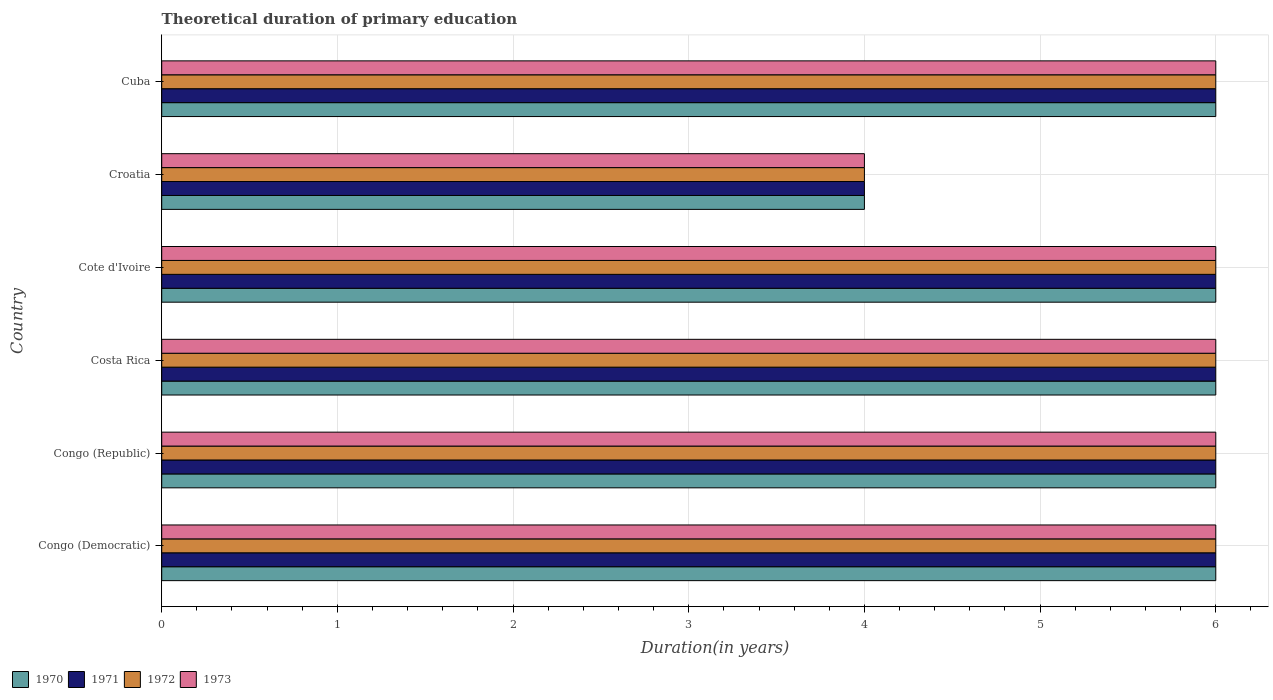How many different coloured bars are there?
Give a very brief answer. 4. What is the label of the 3rd group of bars from the top?
Your answer should be compact. Cote d'Ivoire. What is the total theoretical duration of primary education in 1973 in Croatia?
Give a very brief answer. 4. Across all countries, what is the maximum total theoretical duration of primary education in 1970?
Offer a very short reply. 6. Across all countries, what is the minimum total theoretical duration of primary education in 1972?
Provide a short and direct response. 4. In which country was the total theoretical duration of primary education in 1971 maximum?
Your response must be concise. Congo (Democratic). In which country was the total theoretical duration of primary education in 1970 minimum?
Offer a terse response. Croatia. What is the total total theoretical duration of primary education in 1972 in the graph?
Offer a very short reply. 34. What is the difference between the total theoretical duration of primary education in 1972 in Congo (Democratic) and the total theoretical duration of primary education in 1973 in Cote d'Ivoire?
Offer a terse response. 0. What is the average total theoretical duration of primary education in 1972 per country?
Your answer should be compact. 5.67. What is the difference between the total theoretical duration of primary education in 1971 and total theoretical duration of primary education in 1973 in Croatia?
Offer a terse response. 0. Is the total theoretical duration of primary education in 1973 in Cote d'Ivoire less than that in Croatia?
Offer a terse response. No. Is the difference between the total theoretical duration of primary education in 1971 in Cote d'Ivoire and Croatia greater than the difference between the total theoretical duration of primary education in 1973 in Cote d'Ivoire and Croatia?
Your response must be concise. No. What is the difference between the highest and the second highest total theoretical duration of primary education in 1972?
Ensure brevity in your answer.  0. What does the 1st bar from the top in Costa Rica represents?
Ensure brevity in your answer.  1973. How many bars are there?
Your response must be concise. 24. Are the values on the major ticks of X-axis written in scientific E-notation?
Provide a succinct answer. No. Where does the legend appear in the graph?
Keep it short and to the point. Bottom left. How many legend labels are there?
Your response must be concise. 4. How are the legend labels stacked?
Your answer should be compact. Horizontal. What is the title of the graph?
Your answer should be compact. Theoretical duration of primary education. What is the label or title of the X-axis?
Give a very brief answer. Duration(in years). What is the label or title of the Y-axis?
Give a very brief answer. Country. What is the Duration(in years) of 1970 in Congo (Democratic)?
Provide a succinct answer. 6. What is the Duration(in years) in 1972 in Congo (Democratic)?
Keep it short and to the point. 6. What is the Duration(in years) of 1973 in Congo (Democratic)?
Your response must be concise. 6. What is the Duration(in years) in 1971 in Congo (Republic)?
Offer a very short reply. 6. What is the Duration(in years) of 1972 in Congo (Republic)?
Keep it short and to the point. 6. What is the Duration(in years) in 1973 in Congo (Republic)?
Keep it short and to the point. 6. What is the Duration(in years) of 1970 in Costa Rica?
Give a very brief answer. 6. What is the Duration(in years) in 1971 in Costa Rica?
Your answer should be compact. 6. What is the Duration(in years) in 1973 in Costa Rica?
Your answer should be very brief. 6. What is the Duration(in years) of 1970 in Cote d'Ivoire?
Provide a succinct answer. 6. What is the Duration(in years) of 1972 in Cote d'Ivoire?
Ensure brevity in your answer.  6. What is the Duration(in years) in 1973 in Cote d'Ivoire?
Ensure brevity in your answer.  6. What is the Duration(in years) of 1970 in Croatia?
Give a very brief answer. 4. What is the Duration(in years) in 1972 in Cuba?
Make the answer very short. 6. What is the Duration(in years) of 1973 in Cuba?
Provide a succinct answer. 6. Across all countries, what is the maximum Duration(in years) in 1970?
Offer a terse response. 6. Across all countries, what is the maximum Duration(in years) of 1973?
Keep it short and to the point. 6. Across all countries, what is the minimum Duration(in years) in 1973?
Provide a succinct answer. 4. What is the total Duration(in years) of 1970 in the graph?
Your answer should be compact. 34. What is the difference between the Duration(in years) of 1971 in Congo (Democratic) and that in Congo (Republic)?
Provide a succinct answer. 0. What is the difference between the Duration(in years) in 1973 in Congo (Democratic) and that in Congo (Republic)?
Make the answer very short. 0. What is the difference between the Duration(in years) in 1970 in Congo (Democratic) and that in Cote d'Ivoire?
Your answer should be compact. 0. What is the difference between the Duration(in years) in 1972 in Congo (Democratic) and that in Cote d'Ivoire?
Your answer should be very brief. 0. What is the difference between the Duration(in years) of 1970 in Congo (Democratic) and that in Croatia?
Provide a short and direct response. 2. What is the difference between the Duration(in years) in 1973 in Congo (Democratic) and that in Croatia?
Offer a very short reply. 2. What is the difference between the Duration(in years) in 1970 in Congo (Democratic) and that in Cuba?
Offer a terse response. 0. What is the difference between the Duration(in years) in 1971 in Congo (Democratic) and that in Cuba?
Offer a very short reply. 0. What is the difference between the Duration(in years) in 1973 in Congo (Democratic) and that in Cuba?
Provide a succinct answer. 0. What is the difference between the Duration(in years) in 1971 in Congo (Republic) and that in Costa Rica?
Ensure brevity in your answer.  0. What is the difference between the Duration(in years) in 1971 in Congo (Republic) and that in Cote d'Ivoire?
Give a very brief answer. 0. What is the difference between the Duration(in years) of 1973 in Congo (Republic) and that in Cote d'Ivoire?
Make the answer very short. 0. What is the difference between the Duration(in years) of 1971 in Congo (Republic) and that in Croatia?
Offer a very short reply. 2. What is the difference between the Duration(in years) of 1972 in Congo (Republic) and that in Croatia?
Provide a short and direct response. 2. What is the difference between the Duration(in years) in 1971 in Congo (Republic) and that in Cuba?
Offer a terse response. 0. What is the difference between the Duration(in years) in 1971 in Costa Rica and that in Cote d'Ivoire?
Give a very brief answer. 0. What is the difference between the Duration(in years) in 1970 in Costa Rica and that in Croatia?
Provide a succinct answer. 2. What is the difference between the Duration(in years) in 1971 in Costa Rica and that in Croatia?
Provide a short and direct response. 2. What is the difference between the Duration(in years) in 1972 in Costa Rica and that in Croatia?
Your answer should be very brief. 2. What is the difference between the Duration(in years) of 1970 in Costa Rica and that in Cuba?
Offer a very short reply. 0. What is the difference between the Duration(in years) in 1972 in Costa Rica and that in Cuba?
Your answer should be very brief. 0. What is the difference between the Duration(in years) in 1973 in Costa Rica and that in Cuba?
Provide a short and direct response. 0. What is the difference between the Duration(in years) in 1972 in Cote d'Ivoire and that in Croatia?
Provide a short and direct response. 2. What is the difference between the Duration(in years) of 1973 in Cote d'Ivoire and that in Croatia?
Offer a terse response. 2. What is the difference between the Duration(in years) of 1970 in Cote d'Ivoire and that in Cuba?
Your answer should be compact. 0. What is the difference between the Duration(in years) in 1972 in Cote d'Ivoire and that in Cuba?
Your answer should be compact. 0. What is the difference between the Duration(in years) of 1971 in Croatia and that in Cuba?
Ensure brevity in your answer.  -2. What is the difference between the Duration(in years) of 1972 in Croatia and that in Cuba?
Provide a succinct answer. -2. What is the difference between the Duration(in years) of 1973 in Croatia and that in Cuba?
Offer a very short reply. -2. What is the difference between the Duration(in years) in 1970 in Congo (Democratic) and the Duration(in years) in 1972 in Congo (Republic)?
Your answer should be compact. 0. What is the difference between the Duration(in years) of 1970 in Congo (Democratic) and the Duration(in years) of 1973 in Congo (Republic)?
Your answer should be very brief. 0. What is the difference between the Duration(in years) of 1971 in Congo (Democratic) and the Duration(in years) of 1972 in Congo (Republic)?
Offer a very short reply. 0. What is the difference between the Duration(in years) of 1972 in Congo (Democratic) and the Duration(in years) of 1973 in Congo (Republic)?
Provide a succinct answer. 0. What is the difference between the Duration(in years) in 1970 in Congo (Democratic) and the Duration(in years) in 1971 in Costa Rica?
Offer a terse response. 0. What is the difference between the Duration(in years) of 1971 in Congo (Democratic) and the Duration(in years) of 1972 in Costa Rica?
Offer a very short reply. 0. What is the difference between the Duration(in years) in 1971 in Congo (Democratic) and the Duration(in years) in 1973 in Costa Rica?
Your answer should be compact. 0. What is the difference between the Duration(in years) of 1970 in Congo (Democratic) and the Duration(in years) of 1971 in Cote d'Ivoire?
Keep it short and to the point. 0. What is the difference between the Duration(in years) in 1970 in Congo (Democratic) and the Duration(in years) in 1973 in Cote d'Ivoire?
Your answer should be very brief. 0. What is the difference between the Duration(in years) of 1971 in Congo (Democratic) and the Duration(in years) of 1973 in Cote d'Ivoire?
Your answer should be very brief. 0. What is the difference between the Duration(in years) in 1970 in Congo (Democratic) and the Duration(in years) in 1971 in Croatia?
Keep it short and to the point. 2. What is the difference between the Duration(in years) of 1970 in Congo (Democratic) and the Duration(in years) of 1973 in Croatia?
Your response must be concise. 2. What is the difference between the Duration(in years) in 1972 in Congo (Democratic) and the Duration(in years) in 1973 in Cuba?
Your response must be concise. 0. What is the difference between the Duration(in years) in 1970 in Congo (Republic) and the Duration(in years) in 1972 in Costa Rica?
Ensure brevity in your answer.  0. What is the difference between the Duration(in years) in 1971 in Congo (Republic) and the Duration(in years) in 1972 in Costa Rica?
Provide a succinct answer. 0. What is the difference between the Duration(in years) of 1971 in Congo (Republic) and the Duration(in years) of 1973 in Costa Rica?
Provide a succinct answer. 0. What is the difference between the Duration(in years) in 1970 in Congo (Republic) and the Duration(in years) in 1971 in Cote d'Ivoire?
Make the answer very short. 0. What is the difference between the Duration(in years) of 1970 in Congo (Republic) and the Duration(in years) of 1972 in Cote d'Ivoire?
Offer a very short reply. 0. What is the difference between the Duration(in years) of 1971 in Congo (Republic) and the Duration(in years) of 1972 in Cote d'Ivoire?
Your answer should be compact. 0. What is the difference between the Duration(in years) in 1972 in Congo (Republic) and the Duration(in years) in 1973 in Cote d'Ivoire?
Your response must be concise. 0. What is the difference between the Duration(in years) in 1970 in Congo (Republic) and the Duration(in years) in 1971 in Croatia?
Your response must be concise. 2. What is the difference between the Duration(in years) of 1970 in Congo (Republic) and the Duration(in years) of 1972 in Croatia?
Ensure brevity in your answer.  2. What is the difference between the Duration(in years) in 1971 in Congo (Republic) and the Duration(in years) in 1973 in Croatia?
Provide a succinct answer. 2. What is the difference between the Duration(in years) in 1970 in Congo (Republic) and the Duration(in years) in 1973 in Cuba?
Make the answer very short. 0. What is the difference between the Duration(in years) of 1971 in Congo (Republic) and the Duration(in years) of 1972 in Cuba?
Offer a terse response. 0. What is the difference between the Duration(in years) in 1971 in Costa Rica and the Duration(in years) in 1972 in Cote d'Ivoire?
Your response must be concise. 0. What is the difference between the Duration(in years) of 1971 in Costa Rica and the Duration(in years) of 1973 in Cote d'Ivoire?
Your answer should be compact. 0. What is the difference between the Duration(in years) in 1970 in Costa Rica and the Duration(in years) in 1971 in Croatia?
Make the answer very short. 2. What is the difference between the Duration(in years) in 1970 in Costa Rica and the Duration(in years) in 1973 in Croatia?
Offer a terse response. 2. What is the difference between the Duration(in years) of 1971 in Costa Rica and the Duration(in years) of 1973 in Croatia?
Your answer should be very brief. 2. What is the difference between the Duration(in years) in 1972 in Costa Rica and the Duration(in years) in 1973 in Croatia?
Your response must be concise. 2. What is the difference between the Duration(in years) of 1970 in Costa Rica and the Duration(in years) of 1971 in Cuba?
Provide a short and direct response. 0. What is the difference between the Duration(in years) in 1970 in Costa Rica and the Duration(in years) in 1972 in Cuba?
Provide a short and direct response. 0. What is the difference between the Duration(in years) of 1971 in Costa Rica and the Duration(in years) of 1973 in Cuba?
Keep it short and to the point. 0. What is the difference between the Duration(in years) in 1972 in Costa Rica and the Duration(in years) in 1973 in Cuba?
Make the answer very short. 0. What is the difference between the Duration(in years) of 1970 in Cote d'Ivoire and the Duration(in years) of 1971 in Croatia?
Offer a very short reply. 2. What is the difference between the Duration(in years) of 1970 in Cote d'Ivoire and the Duration(in years) of 1972 in Croatia?
Ensure brevity in your answer.  2. What is the difference between the Duration(in years) in 1970 in Cote d'Ivoire and the Duration(in years) in 1973 in Croatia?
Offer a terse response. 2. What is the difference between the Duration(in years) in 1971 in Cote d'Ivoire and the Duration(in years) in 1972 in Croatia?
Give a very brief answer. 2. What is the difference between the Duration(in years) of 1972 in Cote d'Ivoire and the Duration(in years) of 1973 in Croatia?
Ensure brevity in your answer.  2. What is the difference between the Duration(in years) of 1970 in Cote d'Ivoire and the Duration(in years) of 1971 in Cuba?
Make the answer very short. 0. What is the difference between the Duration(in years) of 1970 in Cote d'Ivoire and the Duration(in years) of 1972 in Cuba?
Provide a succinct answer. 0. What is the difference between the Duration(in years) in 1970 in Cote d'Ivoire and the Duration(in years) in 1973 in Cuba?
Provide a succinct answer. 0. What is the difference between the Duration(in years) in 1971 in Cote d'Ivoire and the Duration(in years) in 1973 in Cuba?
Provide a succinct answer. 0. What is the difference between the Duration(in years) of 1970 in Croatia and the Duration(in years) of 1971 in Cuba?
Offer a terse response. -2. What is the average Duration(in years) in 1970 per country?
Give a very brief answer. 5.67. What is the average Duration(in years) in 1971 per country?
Your answer should be very brief. 5.67. What is the average Duration(in years) of 1972 per country?
Your response must be concise. 5.67. What is the average Duration(in years) in 1973 per country?
Give a very brief answer. 5.67. What is the difference between the Duration(in years) in 1970 and Duration(in years) in 1973 in Congo (Democratic)?
Make the answer very short. 0. What is the difference between the Duration(in years) in 1972 and Duration(in years) in 1973 in Congo (Democratic)?
Ensure brevity in your answer.  0. What is the difference between the Duration(in years) in 1970 and Duration(in years) in 1972 in Congo (Republic)?
Give a very brief answer. 0. What is the difference between the Duration(in years) in 1972 and Duration(in years) in 1973 in Congo (Republic)?
Provide a short and direct response. 0. What is the difference between the Duration(in years) of 1972 and Duration(in years) of 1973 in Costa Rica?
Your answer should be very brief. 0. What is the difference between the Duration(in years) in 1970 and Duration(in years) in 1972 in Cote d'Ivoire?
Offer a terse response. 0. What is the difference between the Duration(in years) in 1970 and Duration(in years) in 1973 in Cote d'Ivoire?
Offer a very short reply. 0. What is the difference between the Duration(in years) in 1971 and Duration(in years) in 1973 in Cote d'Ivoire?
Provide a succinct answer. 0. What is the difference between the Duration(in years) in 1970 and Duration(in years) in 1971 in Croatia?
Your answer should be compact. 0. What is the difference between the Duration(in years) of 1970 and Duration(in years) of 1973 in Croatia?
Ensure brevity in your answer.  0. What is the difference between the Duration(in years) of 1970 and Duration(in years) of 1971 in Cuba?
Keep it short and to the point. 0. What is the difference between the Duration(in years) in 1970 and Duration(in years) in 1972 in Cuba?
Make the answer very short. 0. What is the difference between the Duration(in years) in 1970 and Duration(in years) in 1973 in Cuba?
Offer a very short reply. 0. What is the difference between the Duration(in years) of 1971 and Duration(in years) of 1973 in Cuba?
Provide a succinct answer. 0. What is the ratio of the Duration(in years) in 1970 in Congo (Democratic) to that in Congo (Republic)?
Your answer should be compact. 1. What is the ratio of the Duration(in years) of 1971 in Congo (Democratic) to that in Costa Rica?
Your answer should be very brief. 1. What is the ratio of the Duration(in years) of 1973 in Congo (Democratic) to that in Costa Rica?
Ensure brevity in your answer.  1. What is the ratio of the Duration(in years) in 1970 in Congo (Democratic) to that in Cote d'Ivoire?
Provide a succinct answer. 1. What is the ratio of the Duration(in years) of 1972 in Congo (Democratic) to that in Cote d'Ivoire?
Offer a terse response. 1. What is the ratio of the Duration(in years) of 1973 in Congo (Democratic) to that in Cote d'Ivoire?
Offer a very short reply. 1. What is the ratio of the Duration(in years) in 1970 in Congo (Democratic) to that in Croatia?
Provide a succinct answer. 1.5. What is the ratio of the Duration(in years) of 1972 in Congo (Democratic) to that in Croatia?
Keep it short and to the point. 1.5. What is the ratio of the Duration(in years) of 1971 in Congo (Democratic) to that in Cuba?
Offer a very short reply. 1. What is the ratio of the Duration(in years) in 1973 in Congo (Democratic) to that in Cuba?
Make the answer very short. 1. What is the ratio of the Duration(in years) in 1970 in Congo (Republic) to that in Costa Rica?
Your answer should be compact. 1. What is the ratio of the Duration(in years) of 1971 in Congo (Republic) to that in Cote d'Ivoire?
Keep it short and to the point. 1. What is the ratio of the Duration(in years) of 1973 in Congo (Republic) to that in Cote d'Ivoire?
Provide a short and direct response. 1. What is the ratio of the Duration(in years) of 1973 in Congo (Republic) to that in Croatia?
Your answer should be very brief. 1.5. What is the ratio of the Duration(in years) in 1971 in Congo (Republic) to that in Cuba?
Ensure brevity in your answer.  1. What is the ratio of the Duration(in years) in 1972 in Congo (Republic) to that in Cuba?
Make the answer very short. 1. What is the ratio of the Duration(in years) of 1973 in Congo (Republic) to that in Cuba?
Make the answer very short. 1. What is the ratio of the Duration(in years) of 1970 in Costa Rica to that in Cote d'Ivoire?
Offer a terse response. 1. What is the ratio of the Duration(in years) in 1971 in Costa Rica to that in Cote d'Ivoire?
Offer a terse response. 1. What is the ratio of the Duration(in years) of 1973 in Costa Rica to that in Cote d'Ivoire?
Offer a terse response. 1. What is the ratio of the Duration(in years) of 1970 in Costa Rica to that in Croatia?
Offer a terse response. 1.5. What is the ratio of the Duration(in years) of 1973 in Costa Rica to that in Croatia?
Your answer should be very brief. 1.5. What is the ratio of the Duration(in years) of 1971 in Costa Rica to that in Cuba?
Your answer should be compact. 1. What is the ratio of the Duration(in years) of 1972 in Costa Rica to that in Cuba?
Offer a very short reply. 1. What is the ratio of the Duration(in years) of 1972 in Cote d'Ivoire to that in Croatia?
Offer a very short reply. 1.5. What is the ratio of the Duration(in years) in 1970 in Croatia to that in Cuba?
Offer a very short reply. 0.67. What is the ratio of the Duration(in years) in 1973 in Croatia to that in Cuba?
Offer a very short reply. 0.67. What is the difference between the highest and the second highest Duration(in years) of 1971?
Keep it short and to the point. 0. What is the difference between the highest and the second highest Duration(in years) of 1973?
Your answer should be compact. 0. What is the difference between the highest and the lowest Duration(in years) in 1970?
Make the answer very short. 2. What is the difference between the highest and the lowest Duration(in years) in 1971?
Provide a succinct answer. 2. What is the difference between the highest and the lowest Duration(in years) in 1972?
Your response must be concise. 2. 